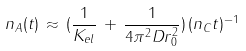<formula> <loc_0><loc_0><loc_500><loc_500>n _ { A } ( t ) \, \approx \, ( \frac { 1 } { K _ { e l } } \, + \, \frac { 1 } { 4 \pi ^ { 2 } D r _ { 0 } ^ { 2 } } ) \, ( n _ { C } t ) ^ { - 1 }</formula> 